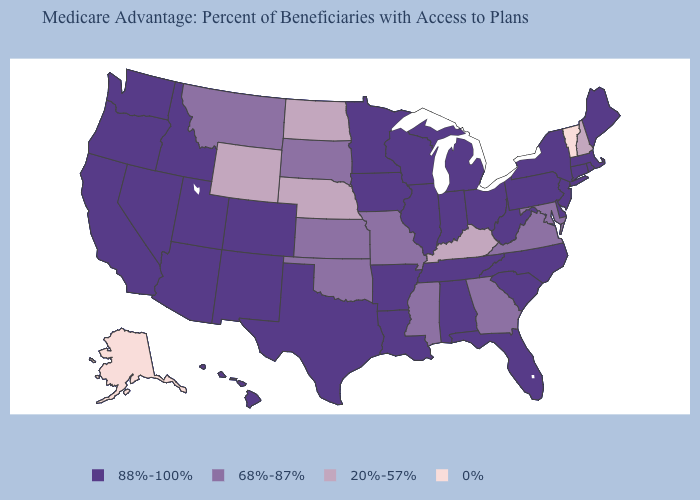Among the states that border Mississippi , which have the lowest value?
Write a very short answer. Alabama, Arkansas, Louisiana, Tennessee. Among the states that border Delaware , does Maryland have the highest value?
Quick response, please. No. Name the states that have a value in the range 0%?
Concise answer only. Alaska, Vermont. Name the states that have a value in the range 68%-87%?
Short answer required. Georgia, Kansas, Maryland, Missouri, Mississippi, Montana, Oklahoma, South Dakota, Virginia. What is the value of Oklahoma?
Quick response, please. 68%-87%. What is the value of Mississippi?
Concise answer only. 68%-87%. What is the value of Kansas?
Keep it brief. 68%-87%. Name the states that have a value in the range 0%?
Give a very brief answer. Alaska, Vermont. Does Utah have the same value as Georgia?
Short answer required. No. What is the highest value in the MidWest ?
Answer briefly. 88%-100%. Name the states that have a value in the range 68%-87%?
Be succinct. Georgia, Kansas, Maryland, Missouri, Mississippi, Montana, Oklahoma, South Dakota, Virginia. What is the lowest value in the USA?
Write a very short answer. 0%. What is the value of Washington?
Give a very brief answer. 88%-100%. Which states have the lowest value in the USA?
Short answer required. Alaska, Vermont. What is the value of Georgia?
Concise answer only. 68%-87%. 